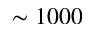Convert formula to latex. <formula><loc_0><loc_0><loc_500><loc_500>\sim 1 0 0 0</formula> 